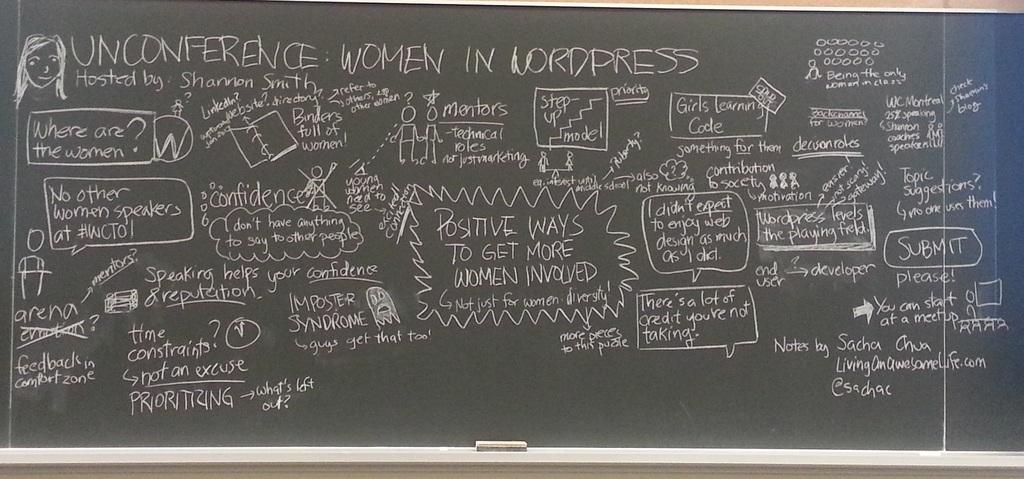<image>
Give a short and clear explanation of the subsequent image. a chalk board that has the word unconference at the top 